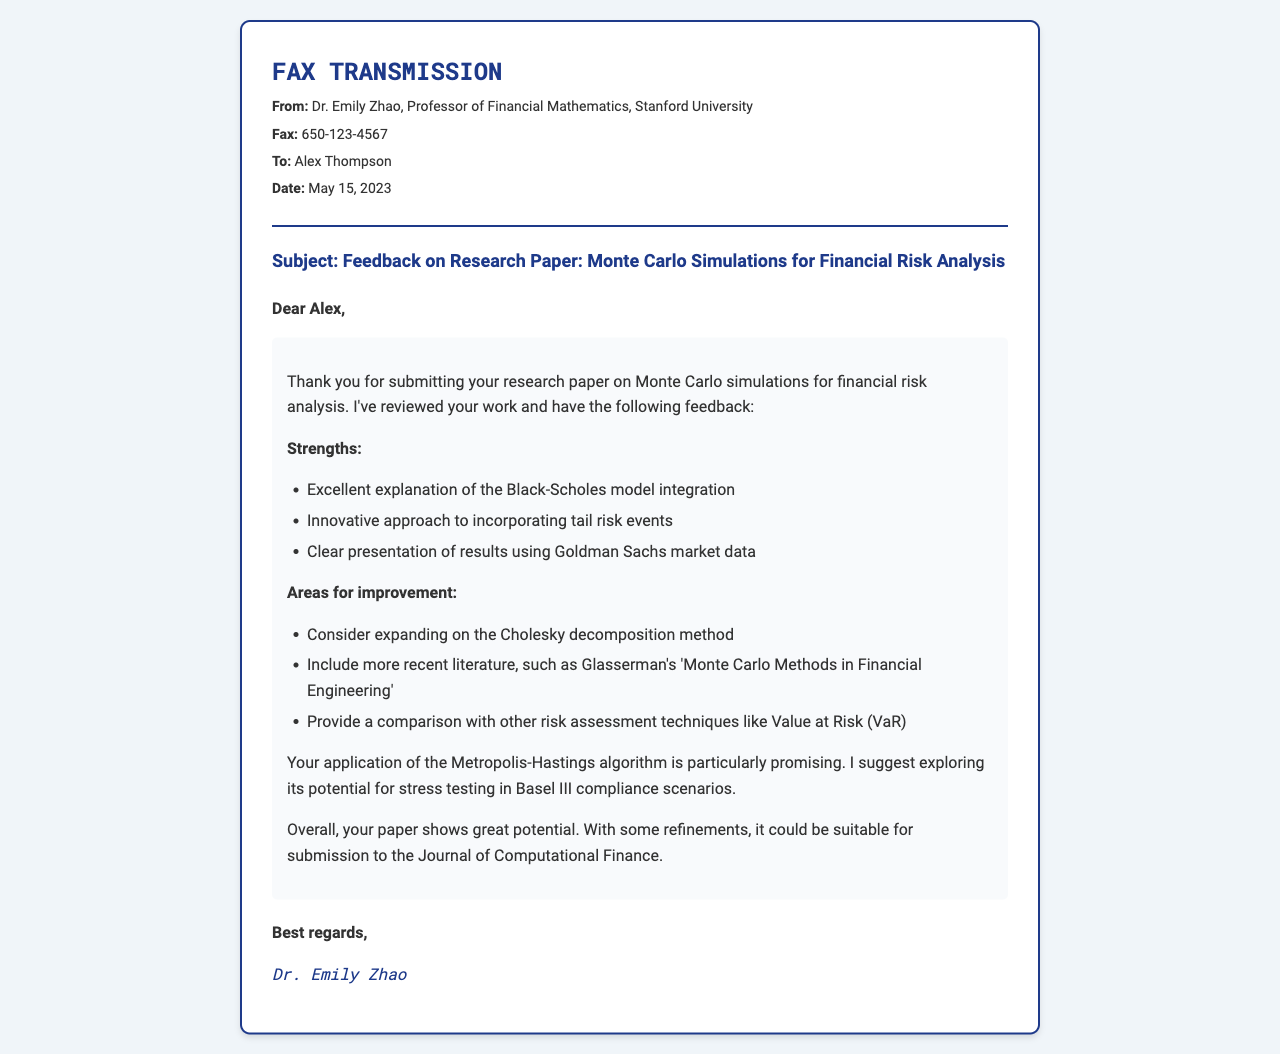what is the name of the professor providing feedback? The name of the professor is mentioned at the top of the document where it says "Dr. Emily Zhao."
Answer: Dr. Emily Zhao what university is the professor affiliated with? The document specifies that the professor is from Stanford University.
Answer: Stanford University what date was the feedback given? The date is indicated in the header of the fax as "May 15, 2023."
Answer: May 15, 2023 what analytical method does the professor suggest expanding on? The document mentions "Cholesky decomposition method" as an area for improvement.
Answer: Cholesky decomposition method which market data was used for presenting results? The professor refers to "Goldman Sachs market data" in the feedback.
Answer: Goldman Sachs market data what promising application is mentioned in the feedback? The feedback highlights the "Metropolis-Hastings algorithm" as particularly promising.
Answer: Metropolis-Hastings algorithm which publication does the professor recommend including in the literature review? The document suggests including "Glasserman's 'Monte Carlo Methods in Financial Engineering.'"
Answer: Glasserman's 'Monte Carlo Methods in Financial Engineering' how does the professor assess the overall potential of the paper? The professor concludes that the paper shows "great potential."
Answer: great potential what could the paper be suitable for submission to? The professor mentions that with some refinements, it could be submitted to the "Journal of Computational Finance."
Answer: Journal of Computational Finance 